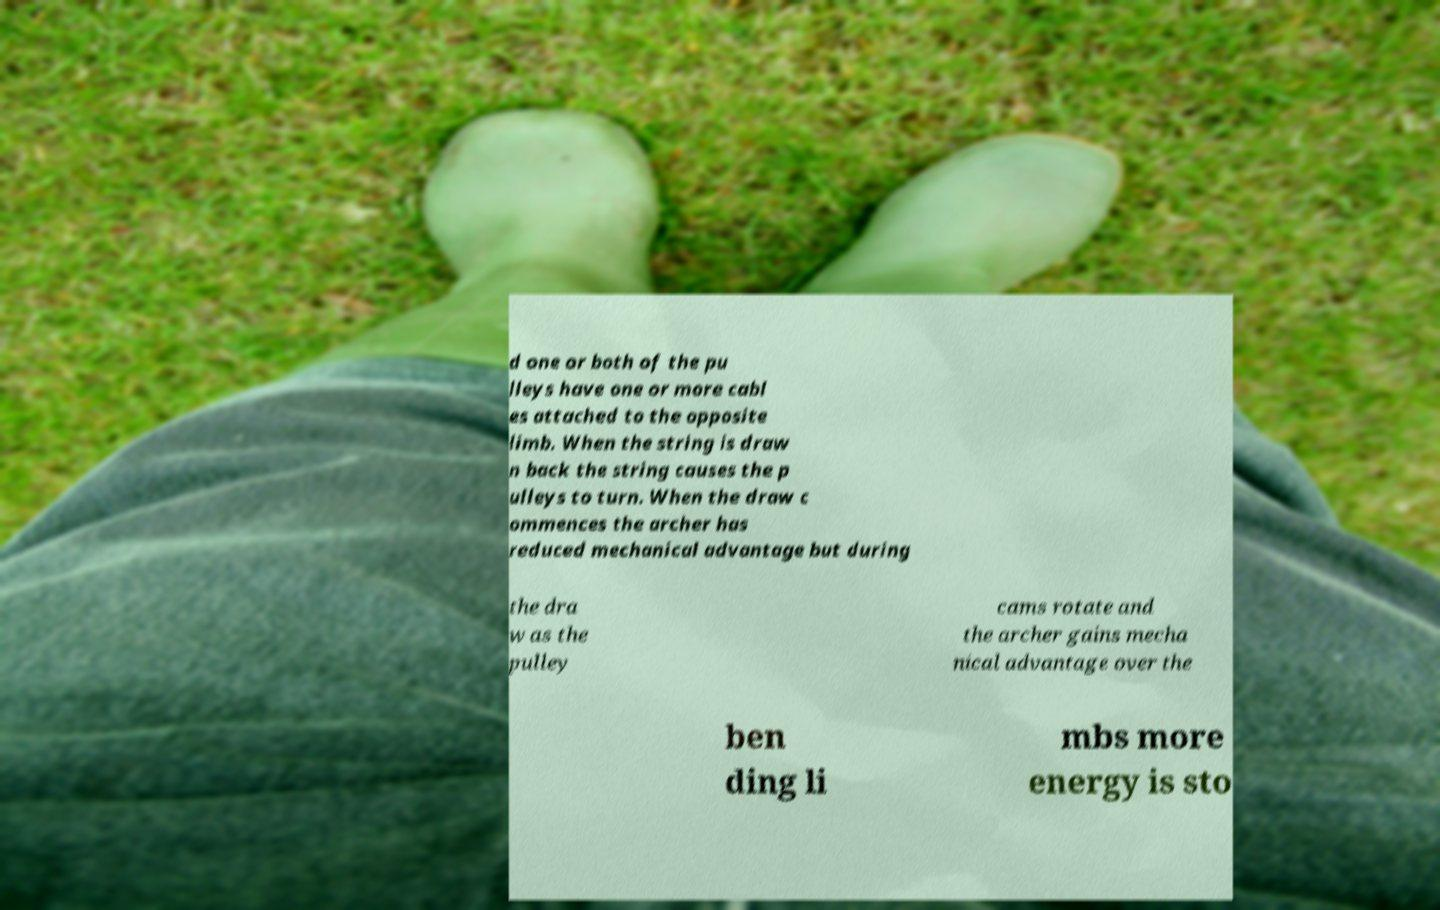Could you assist in decoding the text presented in this image and type it out clearly? d one or both of the pu lleys have one or more cabl es attached to the opposite limb. When the string is draw n back the string causes the p ulleys to turn. When the draw c ommences the archer has reduced mechanical advantage but during the dra w as the pulley cams rotate and the archer gains mecha nical advantage over the ben ding li mbs more energy is sto 